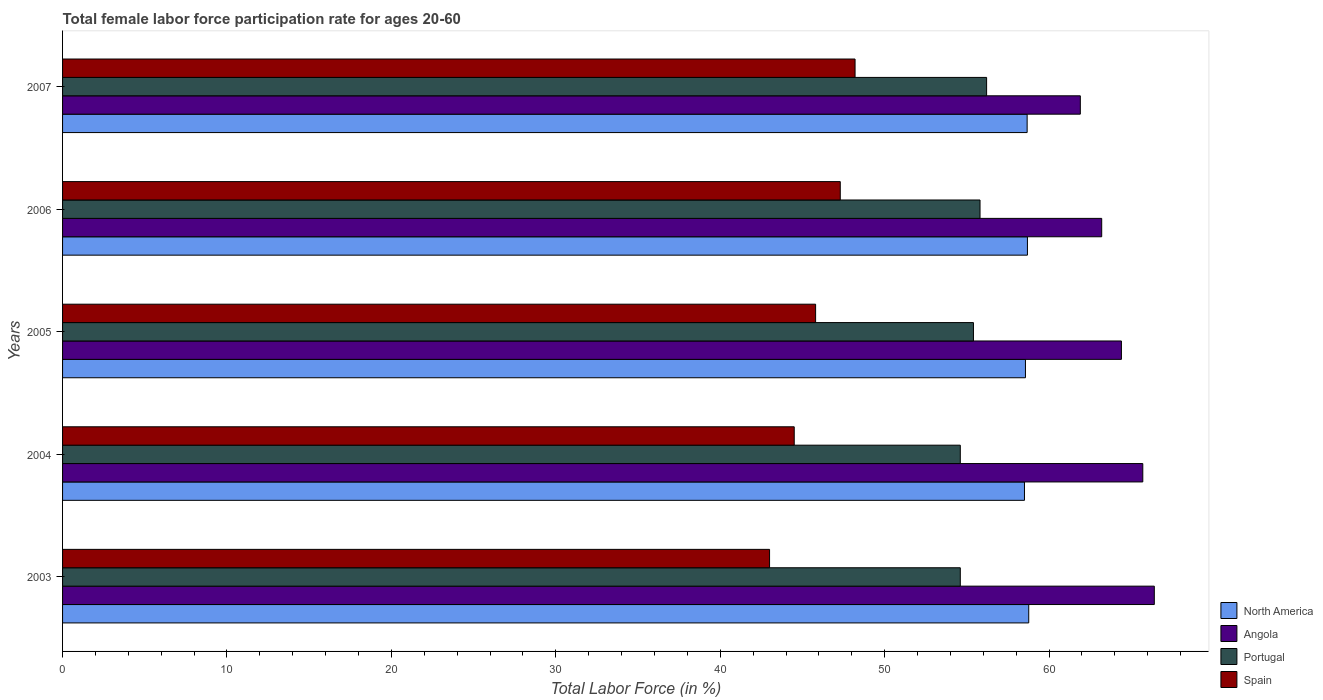Are the number of bars per tick equal to the number of legend labels?
Your answer should be very brief. Yes. How many bars are there on the 5th tick from the bottom?
Your answer should be very brief. 4. What is the label of the 4th group of bars from the top?
Ensure brevity in your answer.  2004. In how many cases, is the number of bars for a given year not equal to the number of legend labels?
Keep it short and to the point. 0. What is the female labor force participation rate in Spain in 2005?
Provide a short and direct response. 45.8. Across all years, what is the maximum female labor force participation rate in Portugal?
Provide a succinct answer. 56.2. Across all years, what is the minimum female labor force participation rate in Portugal?
Offer a terse response. 54.6. What is the total female labor force participation rate in Spain in the graph?
Ensure brevity in your answer.  228.8. What is the difference between the female labor force participation rate in Portugal in 2005 and that in 2007?
Offer a terse response. -0.8. What is the difference between the female labor force participation rate in North America in 2006 and the female labor force participation rate in Portugal in 2007?
Your response must be concise. 2.48. What is the average female labor force participation rate in North America per year?
Offer a very short reply. 58.64. In the year 2006, what is the difference between the female labor force participation rate in North America and female labor force participation rate in Angola?
Give a very brief answer. -4.52. What is the ratio of the female labor force participation rate in Spain in 2005 to that in 2007?
Make the answer very short. 0.95. Is the female labor force participation rate in Portugal in 2003 less than that in 2006?
Your answer should be very brief. Yes. Is the difference between the female labor force participation rate in North America in 2003 and 2006 greater than the difference between the female labor force participation rate in Angola in 2003 and 2006?
Give a very brief answer. No. What is the difference between the highest and the second highest female labor force participation rate in Angola?
Offer a very short reply. 0.7. What is the difference between the highest and the lowest female labor force participation rate in North America?
Your answer should be compact. 0.26. Is the sum of the female labor force participation rate in Spain in 2003 and 2007 greater than the maximum female labor force participation rate in North America across all years?
Your answer should be compact. Yes. Is it the case that in every year, the sum of the female labor force participation rate in North America and female labor force participation rate in Angola is greater than the sum of female labor force participation rate in Portugal and female labor force participation rate in Spain?
Your answer should be compact. No. What does the 4th bar from the bottom in 2006 represents?
Your answer should be very brief. Spain. Is it the case that in every year, the sum of the female labor force participation rate in North America and female labor force participation rate in Angola is greater than the female labor force participation rate in Spain?
Offer a terse response. Yes. Are all the bars in the graph horizontal?
Your answer should be compact. Yes. How many years are there in the graph?
Your response must be concise. 5. Are the values on the major ticks of X-axis written in scientific E-notation?
Ensure brevity in your answer.  No. Where does the legend appear in the graph?
Make the answer very short. Bottom right. How are the legend labels stacked?
Keep it short and to the point. Vertical. What is the title of the graph?
Your response must be concise. Total female labor force participation rate for ages 20-60. Does "Oman" appear as one of the legend labels in the graph?
Ensure brevity in your answer.  No. What is the label or title of the Y-axis?
Provide a short and direct response. Years. What is the Total Labor Force (in %) in North America in 2003?
Provide a short and direct response. 58.76. What is the Total Labor Force (in %) of Angola in 2003?
Your response must be concise. 66.4. What is the Total Labor Force (in %) in Portugal in 2003?
Your answer should be compact. 54.6. What is the Total Labor Force (in %) of North America in 2004?
Your answer should be very brief. 58.5. What is the Total Labor Force (in %) of Angola in 2004?
Give a very brief answer. 65.7. What is the Total Labor Force (in %) of Portugal in 2004?
Make the answer very short. 54.6. What is the Total Labor Force (in %) in Spain in 2004?
Give a very brief answer. 44.5. What is the Total Labor Force (in %) in North America in 2005?
Your response must be concise. 58.56. What is the Total Labor Force (in %) in Angola in 2005?
Ensure brevity in your answer.  64.4. What is the Total Labor Force (in %) in Portugal in 2005?
Provide a succinct answer. 55.4. What is the Total Labor Force (in %) in Spain in 2005?
Give a very brief answer. 45.8. What is the Total Labor Force (in %) in North America in 2006?
Ensure brevity in your answer.  58.68. What is the Total Labor Force (in %) in Angola in 2006?
Make the answer very short. 63.2. What is the Total Labor Force (in %) of Portugal in 2006?
Your response must be concise. 55.8. What is the Total Labor Force (in %) in Spain in 2006?
Provide a succinct answer. 47.3. What is the Total Labor Force (in %) of North America in 2007?
Your answer should be very brief. 58.67. What is the Total Labor Force (in %) of Angola in 2007?
Your answer should be compact. 61.9. What is the Total Labor Force (in %) of Portugal in 2007?
Ensure brevity in your answer.  56.2. What is the Total Labor Force (in %) of Spain in 2007?
Your response must be concise. 48.2. Across all years, what is the maximum Total Labor Force (in %) in North America?
Offer a very short reply. 58.76. Across all years, what is the maximum Total Labor Force (in %) in Angola?
Your answer should be very brief. 66.4. Across all years, what is the maximum Total Labor Force (in %) of Portugal?
Your answer should be very brief. 56.2. Across all years, what is the maximum Total Labor Force (in %) in Spain?
Your answer should be compact. 48.2. Across all years, what is the minimum Total Labor Force (in %) in North America?
Your answer should be very brief. 58.5. Across all years, what is the minimum Total Labor Force (in %) in Angola?
Give a very brief answer. 61.9. Across all years, what is the minimum Total Labor Force (in %) of Portugal?
Offer a very short reply. 54.6. What is the total Total Labor Force (in %) of North America in the graph?
Offer a very short reply. 293.18. What is the total Total Labor Force (in %) in Angola in the graph?
Your answer should be very brief. 321.6. What is the total Total Labor Force (in %) in Portugal in the graph?
Your response must be concise. 276.6. What is the total Total Labor Force (in %) in Spain in the graph?
Your answer should be compact. 228.8. What is the difference between the Total Labor Force (in %) of North America in 2003 and that in 2004?
Provide a succinct answer. 0.26. What is the difference between the Total Labor Force (in %) of Angola in 2003 and that in 2004?
Keep it short and to the point. 0.7. What is the difference between the Total Labor Force (in %) in Spain in 2003 and that in 2004?
Provide a succinct answer. -1.5. What is the difference between the Total Labor Force (in %) of North America in 2003 and that in 2005?
Provide a succinct answer. 0.2. What is the difference between the Total Labor Force (in %) of Angola in 2003 and that in 2005?
Provide a succinct answer. 2. What is the difference between the Total Labor Force (in %) in North America in 2003 and that in 2006?
Offer a very short reply. 0.08. What is the difference between the Total Labor Force (in %) of Angola in 2003 and that in 2006?
Your response must be concise. 3.2. What is the difference between the Total Labor Force (in %) of Portugal in 2003 and that in 2006?
Your response must be concise. -1.2. What is the difference between the Total Labor Force (in %) of North America in 2003 and that in 2007?
Your answer should be compact. 0.1. What is the difference between the Total Labor Force (in %) of North America in 2004 and that in 2005?
Keep it short and to the point. -0.06. What is the difference between the Total Labor Force (in %) of Angola in 2004 and that in 2005?
Make the answer very short. 1.3. What is the difference between the Total Labor Force (in %) of Portugal in 2004 and that in 2005?
Offer a terse response. -0.8. What is the difference between the Total Labor Force (in %) in North America in 2004 and that in 2006?
Ensure brevity in your answer.  -0.18. What is the difference between the Total Labor Force (in %) in Angola in 2004 and that in 2006?
Ensure brevity in your answer.  2.5. What is the difference between the Total Labor Force (in %) of Portugal in 2004 and that in 2006?
Offer a terse response. -1.2. What is the difference between the Total Labor Force (in %) in Spain in 2004 and that in 2006?
Give a very brief answer. -2.8. What is the difference between the Total Labor Force (in %) in North America in 2004 and that in 2007?
Ensure brevity in your answer.  -0.16. What is the difference between the Total Labor Force (in %) in Angola in 2004 and that in 2007?
Offer a very short reply. 3.8. What is the difference between the Total Labor Force (in %) in Spain in 2004 and that in 2007?
Your answer should be compact. -3.7. What is the difference between the Total Labor Force (in %) in North America in 2005 and that in 2006?
Ensure brevity in your answer.  -0.12. What is the difference between the Total Labor Force (in %) of Angola in 2005 and that in 2006?
Ensure brevity in your answer.  1.2. What is the difference between the Total Labor Force (in %) of Portugal in 2005 and that in 2006?
Offer a very short reply. -0.4. What is the difference between the Total Labor Force (in %) in North America in 2005 and that in 2007?
Keep it short and to the point. -0.1. What is the difference between the Total Labor Force (in %) in North America in 2006 and that in 2007?
Give a very brief answer. 0.02. What is the difference between the Total Labor Force (in %) of Portugal in 2006 and that in 2007?
Your response must be concise. -0.4. What is the difference between the Total Labor Force (in %) in Spain in 2006 and that in 2007?
Offer a very short reply. -0.9. What is the difference between the Total Labor Force (in %) in North America in 2003 and the Total Labor Force (in %) in Angola in 2004?
Provide a short and direct response. -6.94. What is the difference between the Total Labor Force (in %) of North America in 2003 and the Total Labor Force (in %) of Portugal in 2004?
Your answer should be compact. 4.16. What is the difference between the Total Labor Force (in %) in North America in 2003 and the Total Labor Force (in %) in Spain in 2004?
Your answer should be very brief. 14.26. What is the difference between the Total Labor Force (in %) of Angola in 2003 and the Total Labor Force (in %) of Portugal in 2004?
Your response must be concise. 11.8. What is the difference between the Total Labor Force (in %) in Angola in 2003 and the Total Labor Force (in %) in Spain in 2004?
Your answer should be very brief. 21.9. What is the difference between the Total Labor Force (in %) of North America in 2003 and the Total Labor Force (in %) of Angola in 2005?
Offer a very short reply. -5.64. What is the difference between the Total Labor Force (in %) in North America in 2003 and the Total Labor Force (in %) in Portugal in 2005?
Make the answer very short. 3.36. What is the difference between the Total Labor Force (in %) of North America in 2003 and the Total Labor Force (in %) of Spain in 2005?
Ensure brevity in your answer.  12.96. What is the difference between the Total Labor Force (in %) in Angola in 2003 and the Total Labor Force (in %) in Spain in 2005?
Ensure brevity in your answer.  20.6. What is the difference between the Total Labor Force (in %) of Portugal in 2003 and the Total Labor Force (in %) of Spain in 2005?
Offer a very short reply. 8.8. What is the difference between the Total Labor Force (in %) of North America in 2003 and the Total Labor Force (in %) of Angola in 2006?
Make the answer very short. -4.44. What is the difference between the Total Labor Force (in %) of North America in 2003 and the Total Labor Force (in %) of Portugal in 2006?
Make the answer very short. 2.96. What is the difference between the Total Labor Force (in %) in North America in 2003 and the Total Labor Force (in %) in Spain in 2006?
Ensure brevity in your answer.  11.46. What is the difference between the Total Labor Force (in %) in Angola in 2003 and the Total Labor Force (in %) in Portugal in 2006?
Keep it short and to the point. 10.6. What is the difference between the Total Labor Force (in %) in North America in 2003 and the Total Labor Force (in %) in Angola in 2007?
Your response must be concise. -3.14. What is the difference between the Total Labor Force (in %) of North America in 2003 and the Total Labor Force (in %) of Portugal in 2007?
Your answer should be very brief. 2.56. What is the difference between the Total Labor Force (in %) in North America in 2003 and the Total Labor Force (in %) in Spain in 2007?
Your response must be concise. 10.56. What is the difference between the Total Labor Force (in %) in Portugal in 2003 and the Total Labor Force (in %) in Spain in 2007?
Your answer should be compact. 6.4. What is the difference between the Total Labor Force (in %) of North America in 2004 and the Total Labor Force (in %) of Angola in 2005?
Offer a very short reply. -5.9. What is the difference between the Total Labor Force (in %) of North America in 2004 and the Total Labor Force (in %) of Portugal in 2005?
Provide a short and direct response. 3.1. What is the difference between the Total Labor Force (in %) in North America in 2004 and the Total Labor Force (in %) in Spain in 2005?
Provide a succinct answer. 12.7. What is the difference between the Total Labor Force (in %) of Portugal in 2004 and the Total Labor Force (in %) of Spain in 2005?
Make the answer very short. 8.8. What is the difference between the Total Labor Force (in %) in North America in 2004 and the Total Labor Force (in %) in Angola in 2006?
Your answer should be very brief. -4.7. What is the difference between the Total Labor Force (in %) of North America in 2004 and the Total Labor Force (in %) of Portugal in 2006?
Make the answer very short. 2.7. What is the difference between the Total Labor Force (in %) in North America in 2004 and the Total Labor Force (in %) in Spain in 2006?
Your answer should be very brief. 11.2. What is the difference between the Total Labor Force (in %) in Angola in 2004 and the Total Labor Force (in %) in Spain in 2006?
Provide a succinct answer. 18.4. What is the difference between the Total Labor Force (in %) in North America in 2004 and the Total Labor Force (in %) in Angola in 2007?
Provide a short and direct response. -3.4. What is the difference between the Total Labor Force (in %) in North America in 2004 and the Total Labor Force (in %) in Portugal in 2007?
Your answer should be very brief. 2.3. What is the difference between the Total Labor Force (in %) in North America in 2004 and the Total Labor Force (in %) in Spain in 2007?
Your answer should be very brief. 10.3. What is the difference between the Total Labor Force (in %) of Angola in 2004 and the Total Labor Force (in %) of Portugal in 2007?
Your response must be concise. 9.5. What is the difference between the Total Labor Force (in %) in Angola in 2004 and the Total Labor Force (in %) in Spain in 2007?
Keep it short and to the point. 17.5. What is the difference between the Total Labor Force (in %) of North America in 2005 and the Total Labor Force (in %) of Angola in 2006?
Give a very brief answer. -4.64. What is the difference between the Total Labor Force (in %) of North America in 2005 and the Total Labor Force (in %) of Portugal in 2006?
Give a very brief answer. 2.76. What is the difference between the Total Labor Force (in %) in North America in 2005 and the Total Labor Force (in %) in Spain in 2006?
Make the answer very short. 11.26. What is the difference between the Total Labor Force (in %) in Angola in 2005 and the Total Labor Force (in %) in Spain in 2006?
Offer a terse response. 17.1. What is the difference between the Total Labor Force (in %) of North America in 2005 and the Total Labor Force (in %) of Angola in 2007?
Your answer should be compact. -3.34. What is the difference between the Total Labor Force (in %) in North America in 2005 and the Total Labor Force (in %) in Portugal in 2007?
Provide a short and direct response. 2.36. What is the difference between the Total Labor Force (in %) of North America in 2005 and the Total Labor Force (in %) of Spain in 2007?
Your answer should be compact. 10.36. What is the difference between the Total Labor Force (in %) of North America in 2006 and the Total Labor Force (in %) of Angola in 2007?
Provide a short and direct response. -3.22. What is the difference between the Total Labor Force (in %) in North America in 2006 and the Total Labor Force (in %) in Portugal in 2007?
Give a very brief answer. 2.48. What is the difference between the Total Labor Force (in %) in North America in 2006 and the Total Labor Force (in %) in Spain in 2007?
Your response must be concise. 10.48. What is the difference between the Total Labor Force (in %) in Angola in 2006 and the Total Labor Force (in %) in Portugal in 2007?
Your answer should be compact. 7. What is the average Total Labor Force (in %) of North America per year?
Your answer should be compact. 58.64. What is the average Total Labor Force (in %) of Angola per year?
Your answer should be very brief. 64.32. What is the average Total Labor Force (in %) of Portugal per year?
Give a very brief answer. 55.32. What is the average Total Labor Force (in %) in Spain per year?
Offer a terse response. 45.76. In the year 2003, what is the difference between the Total Labor Force (in %) in North America and Total Labor Force (in %) in Angola?
Offer a terse response. -7.64. In the year 2003, what is the difference between the Total Labor Force (in %) of North America and Total Labor Force (in %) of Portugal?
Keep it short and to the point. 4.16. In the year 2003, what is the difference between the Total Labor Force (in %) in North America and Total Labor Force (in %) in Spain?
Your answer should be very brief. 15.76. In the year 2003, what is the difference between the Total Labor Force (in %) of Angola and Total Labor Force (in %) of Spain?
Your response must be concise. 23.4. In the year 2003, what is the difference between the Total Labor Force (in %) of Portugal and Total Labor Force (in %) of Spain?
Keep it short and to the point. 11.6. In the year 2004, what is the difference between the Total Labor Force (in %) in North America and Total Labor Force (in %) in Angola?
Your answer should be compact. -7.2. In the year 2004, what is the difference between the Total Labor Force (in %) in North America and Total Labor Force (in %) in Portugal?
Your answer should be compact. 3.9. In the year 2004, what is the difference between the Total Labor Force (in %) of North America and Total Labor Force (in %) of Spain?
Your response must be concise. 14. In the year 2004, what is the difference between the Total Labor Force (in %) of Angola and Total Labor Force (in %) of Portugal?
Ensure brevity in your answer.  11.1. In the year 2004, what is the difference between the Total Labor Force (in %) of Angola and Total Labor Force (in %) of Spain?
Make the answer very short. 21.2. In the year 2005, what is the difference between the Total Labor Force (in %) of North America and Total Labor Force (in %) of Angola?
Ensure brevity in your answer.  -5.84. In the year 2005, what is the difference between the Total Labor Force (in %) of North America and Total Labor Force (in %) of Portugal?
Your answer should be very brief. 3.16. In the year 2005, what is the difference between the Total Labor Force (in %) of North America and Total Labor Force (in %) of Spain?
Your response must be concise. 12.76. In the year 2005, what is the difference between the Total Labor Force (in %) in Angola and Total Labor Force (in %) in Portugal?
Provide a succinct answer. 9. In the year 2005, what is the difference between the Total Labor Force (in %) in Angola and Total Labor Force (in %) in Spain?
Give a very brief answer. 18.6. In the year 2005, what is the difference between the Total Labor Force (in %) of Portugal and Total Labor Force (in %) of Spain?
Your response must be concise. 9.6. In the year 2006, what is the difference between the Total Labor Force (in %) of North America and Total Labor Force (in %) of Angola?
Your answer should be compact. -4.52. In the year 2006, what is the difference between the Total Labor Force (in %) in North America and Total Labor Force (in %) in Portugal?
Your answer should be compact. 2.88. In the year 2006, what is the difference between the Total Labor Force (in %) in North America and Total Labor Force (in %) in Spain?
Keep it short and to the point. 11.38. In the year 2006, what is the difference between the Total Labor Force (in %) in Angola and Total Labor Force (in %) in Portugal?
Make the answer very short. 7.4. In the year 2007, what is the difference between the Total Labor Force (in %) of North America and Total Labor Force (in %) of Angola?
Provide a short and direct response. -3.23. In the year 2007, what is the difference between the Total Labor Force (in %) in North America and Total Labor Force (in %) in Portugal?
Make the answer very short. 2.47. In the year 2007, what is the difference between the Total Labor Force (in %) of North America and Total Labor Force (in %) of Spain?
Ensure brevity in your answer.  10.47. In the year 2007, what is the difference between the Total Labor Force (in %) of Angola and Total Labor Force (in %) of Spain?
Ensure brevity in your answer.  13.7. What is the ratio of the Total Labor Force (in %) in North America in 2003 to that in 2004?
Provide a succinct answer. 1. What is the ratio of the Total Labor Force (in %) in Angola in 2003 to that in 2004?
Offer a very short reply. 1.01. What is the ratio of the Total Labor Force (in %) in Spain in 2003 to that in 2004?
Provide a short and direct response. 0.97. What is the ratio of the Total Labor Force (in %) in North America in 2003 to that in 2005?
Your answer should be very brief. 1. What is the ratio of the Total Labor Force (in %) in Angola in 2003 to that in 2005?
Provide a succinct answer. 1.03. What is the ratio of the Total Labor Force (in %) in Portugal in 2003 to that in 2005?
Offer a very short reply. 0.99. What is the ratio of the Total Labor Force (in %) in Spain in 2003 to that in 2005?
Provide a short and direct response. 0.94. What is the ratio of the Total Labor Force (in %) in Angola in 2003 to that in 2006?
Provide a succinct answer. 1.05. What is the ratio of the Total Labor Force (in %) in Portugal in 2003 to that in 2006?
Your answer should be very brief. 0.98. What is the ratio of the Total Labor Force (in %) of Angola in 2003 to that in 2007?
Offer a terse response. 1.07. What is the ratio of the Total Labor Force (in %) in Portugal in 2003 to that in 2007?
Offer a terse response. 0.97. What is the ratio of the Total Labor Force (in %) of Spain in 2003 to that in 2007?
Offer a terse response. 0.89. What is the ratio of the Total Labor Force (in %) in North America in 2004 to that in 2005?
Your response must be concise. 1. What is the ratio of the Total Labor Force (in %) of Angola in 2004 to that in 2005?
Provide a short and direct response. 1.02. What is the ratio of the Total Labor Force (in %) in Portugal in 2004 to that in 2005?
Keep it short and to the point. 0.99. What is the ratio of the Total Labor Force (in %) in Spain in 2004 to that in 2005?
Make the answer very short. 0.97. What is the ratio of the Total Labor Force (in %) of North America in 2004 to that in 2006?
Provide a succinct answer. 1. What is the ratio of the Total Labor Force (in %) of Angola in 2004 to that in 2006?
Make the answer very short. 1.04. What is the ratio of the Total Labor Force (in %) of Portugal in 2004 to that in 2006?
Give a very brief answer. 0.98. What is the ratio of the Total Labor Force (in %) in Spain in 2004 to that in 2006?
Provide a short and direct response. 0.94. What is the ratio of the Total Labor Force (in %) of Angola in 2004 to that in 2007?
Offer a very short reply. 1.06. What is the ratio of the Total Labor Force (in %) in Portugal in 2004 to that in 2007?
Keep it short and to the point. 0.97. What is the ratio of the Total Labor Force (in %) in Spain in 2004 to that in 2007?
Your answer should be very brief. 0.92. What is the ratio of the Total Labor Force (in %) of Spain in 2005 to that in 2006?
Give a very brief answer. 0.97. What is the ratio of the Total Labor Force (in %) in Angola in 2005 to that in 2007?
Offer a very short reply. 1.04. What is the ratio of the Total Labor Force (in %) in Portugal in 2005 to that in 2007?
Give a very brief answer. 0.99. What is the ratio of the Total Labor Force (in %) of Spain in 2005 to that in 2007?
Keep it short and to the point. 0.95. What is the ratio of the Total Labor Force (in %) in North America in 2006 to that in 2007?
Provide a succinct answer. 1. What is the ratio of the Total Labor Force (in %) of Angola in 2006 to that in 2007?
Give a very brief answer. 1.02. What is the ratio of the Total Labor Force (in %) in Spain in 2006 to that in 2007?
Ensure brevity in your answer.  0.98. What is the difference between the highest and the second highest Total Labor Force (in %) in North America?
Your response must be concise. 0.08. What is the difference between the highest and the second highest Total Labor Force (in %) in Spain?
Your answer should be very brief. 0.9. What is the difference between the highest and the lowest Total Labor Force (in %) of North America?
Your answer should be compact. 0.26. What is the difference between the highest and the lowest Total Labor Force (in %) in Angola?
Make the answer very short. 4.5. What is the difference between the highest and the lowest Total Labor Force (in %) of Portugal?
Your answer should be compact. 1.6. What is the difference between the highest and the lowest Total Labor Force (in %) of Spain?
Offer a very short reply. 5.2. 